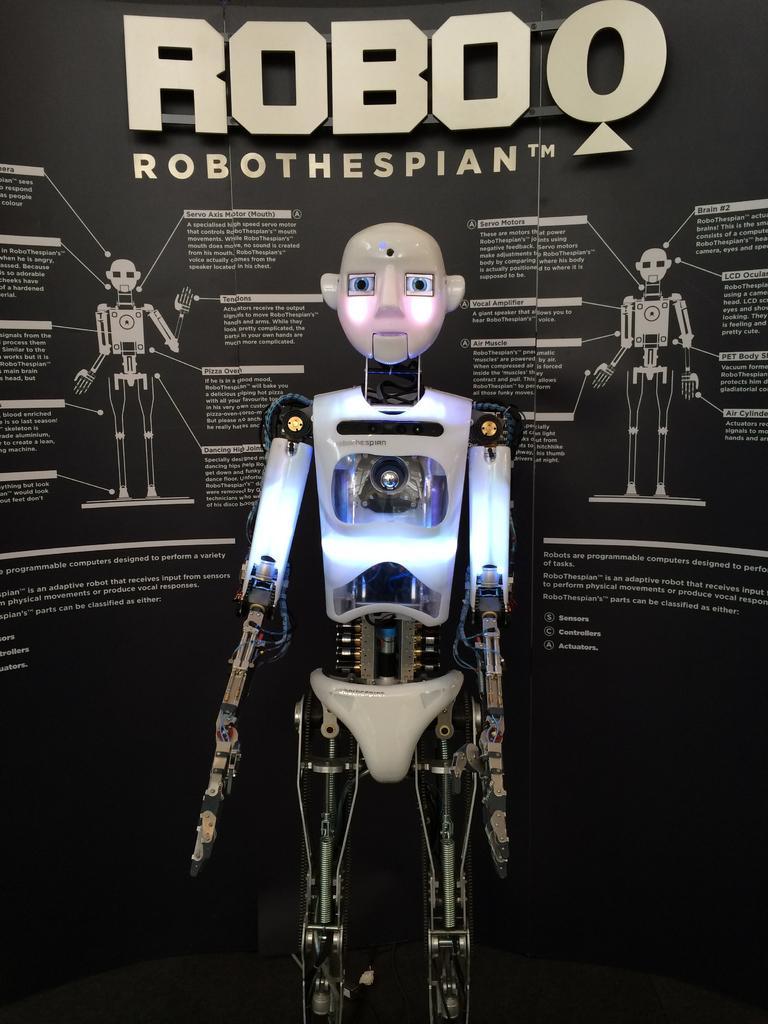Could you give a brief overview of what you see in this image? In this image there is a robot, behind the robot on the wall there is a logo and some text. 